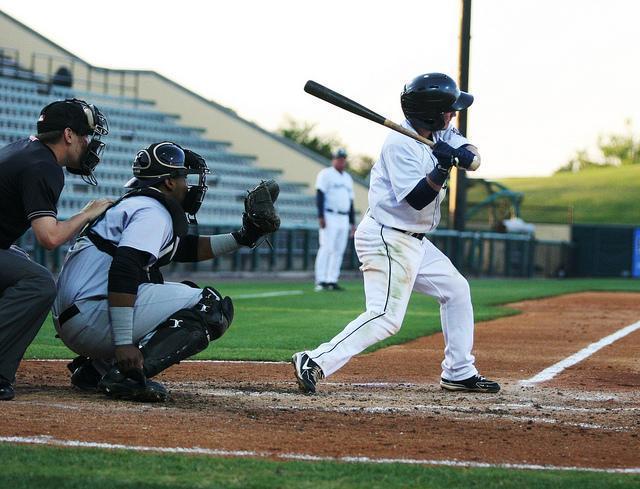How many people are there in the stands?
Give a very brief answer. 0. How many people are visible?
Give a very brief answer. 4. How many train tracks are there?
Give a very brief answer. 0. 